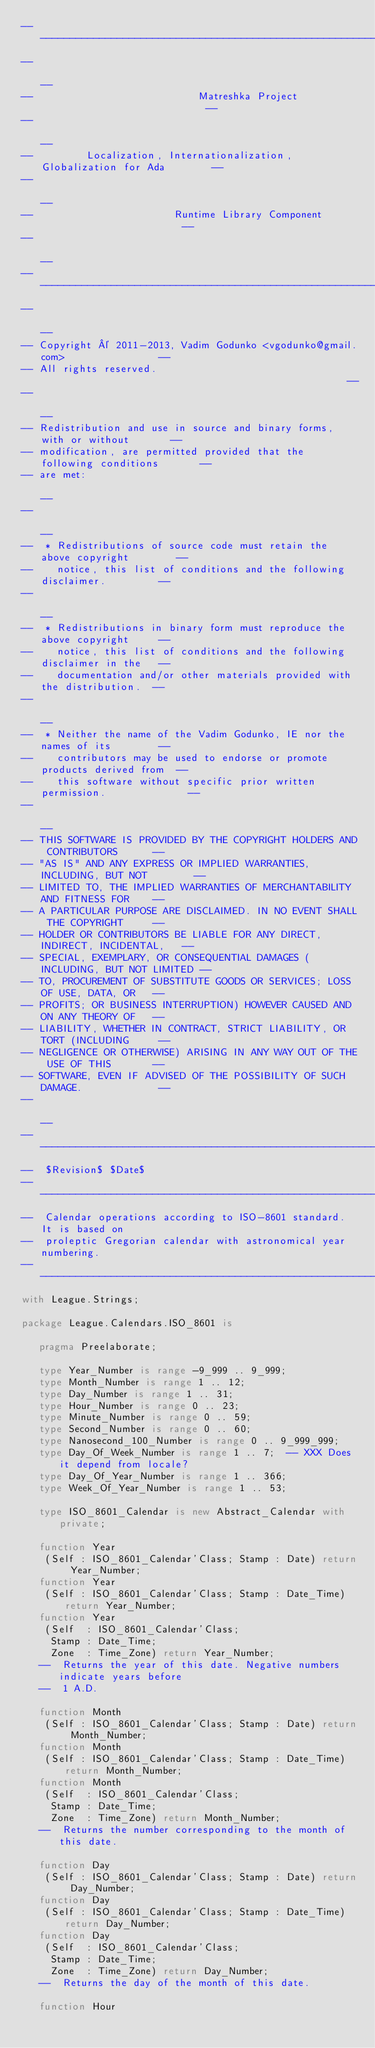<code> <loc_0><loc_0><loc_500><loc_500><_Ada_>------------------------------------------------------------------------------
--                                                                          --
--                            Matreshka Project                             --
--                                                                          --
--         Localization, Internationalization, Globalization for Ada        --
--                                                                          --
--                        Runtime Library Component                         --
--                                                                          --
------------------------------------------------------------------------------
--                                                                          --
-- Copyright © 2011-2013, Vadim Godunko <vgodunko@gmail.com>                --
-- All rights reserved.                                                     --
--                                                                          --
-- Redistribution and use in source and binary forms, with or without       --
-- modification, are permitted provided that the following conditions       --
-- are met:                                                                 --
--                                                                          --
--  * Redistributions of source code must retain the above copyright        --
--    notice, this list of conditions and the following disclaimer.         --
--                                                                          --
--  * Redistributions in binary form must reproduce the above copyright     --
--    notice, this list of conditions and the following disclaimer in the   --
--    documentation and/or other materials provided with the distribution.  --
--                                                                          --
--  * Neither the name of the Vadim Godunko, IE nor the names of its        --
--    contributors may be used to endorse or promote products derived from  --
--    this software without specific prior written permission.              --
--                                                                          --
-- THIS SOFTWARE IS PROVIDED BY THE COPYRIGHT HOLDERS AND CONTRIBUTORS      --
-- "AS IS" AND ANY EXPRESS OR IMPLIED WARRANTIES, INCLUDING, BUT NOT        --
-- LIMITED TO, THE IMPLIED WARRANTIES OF MERCHANTABILITY AND FITNESS FOR    --
-- A PARTICULAR PURPOSE ARE DISCLAIMED. IN NO EVENT SHALL THE COPYRIGHT     --
-- HOLDER OR CONTRIBUTORS BE LIABLE FOR ANY DIRECT, INDIRECT, INCIDENTAL,   --
-- SPECIAL, EXEMPLARY, OR CONSEQUENTIAL DAMAGES (INCLUDING, BUT NOT LIMITED --
-- TO, PROCUREMENT OF SUBSTITUTE GOODS OR SERVICES; LOSS OF USE, DATA, OR   --
-- PROFITS; OR BUSINESS INTERRUPTION) HOWEVER CAUSED AND ON ANY THEORY OF   --
-- LIABILITY, WHETHER IN CONTRACT, STRICT LIABILITY, OR TORT (INCLUDING     --
-- NEGLIGENCE OR OTHERWISE) ARISING IN ANY WAY OUT OF THE USE OF THIS       --
-- SOFTWARE, EVEN IF ADVISED OF THE POSSIBILITY OF SUCH DAMAGE.             --
--                                                                          --
------------------------------------------------------------------------------
--  $Revision$ $Date$
------------------------------------------------------------------------------
--  Calendar operations according to ISO-8601 standard. It is based on
--  proleptic Gregorian calendar with astronomical year numbering.
------------------------------------------------------------------------------
with League.Strings;

package League.Calendars.ISO_8601 is

   pragma Preelaborate;

   type Year_Number is range -9_999 .. 9_999;
   type Month_Number is range 1 .. 12;
   type Day_Number is range 1 .. 31;
   type Hour_Number is range 0 .. 23;
   type Minute_Number is range 0 .. 59;
   type Second_Number is range 0 .. 60;
   type Nanosecond_100_Number is range 0 .. 9_999_999;
   type Day_Of_Week_Number is range 1 .. 7;  -- XXX Does it depend from locale?
   type Day_Of_Year_Number is range 1 .. 366;
   type Week_Of_Year_Number is range 1 .. 53;

   type ISO_8601_Calendar is new Abstract_Calendar with private;

   function Year
    (Self : ISO_8601_Calendar'Class; Stamp : Date) return Year_Number;
   function Year
    (Self : ISO_8601_Calendar'Class; Stamp : Date_Time) return Year_Number;
   function Year
    (Self  : ISO_8601_Calendar'Class;
     Stamp : Date_Time;
     Zone  : Time_Zone) return Year_Number;
   --  Returns the year of this date. Negative numbers indicate years before
   --  1 A.D.

   function Month
    (Self : ISO_8601_Calendar'Class; Stamp : Date) return Month_Number;
   function Month
    (Self : ISO_8601_Calendar'Class; Stamp : Date_Time) return Month_Number;
   function Month
    (Self  : ISO_8601_Calendar'Class;
     Stamp : Date_Time;
     Zone  : Time_Zone) return Month_Number;
   --  Returns the number corresponding to the month of this date.

   function Day
    (Self : ISO_8601_Calendar'Class; Stamp : Date) return Day_Number;
   function Day
    (Self : ISO_8601_Calendar'Class; Stamp : Date_Time) return Day_Number;
   function Day
    (Self  : ISO_8601_Calendar'Class;
     Stamp : Date_Time;
     Zone  : Time_Zone) return Day_Number;
   --  Returns the day of the month of this date.

   function Hour</code> 